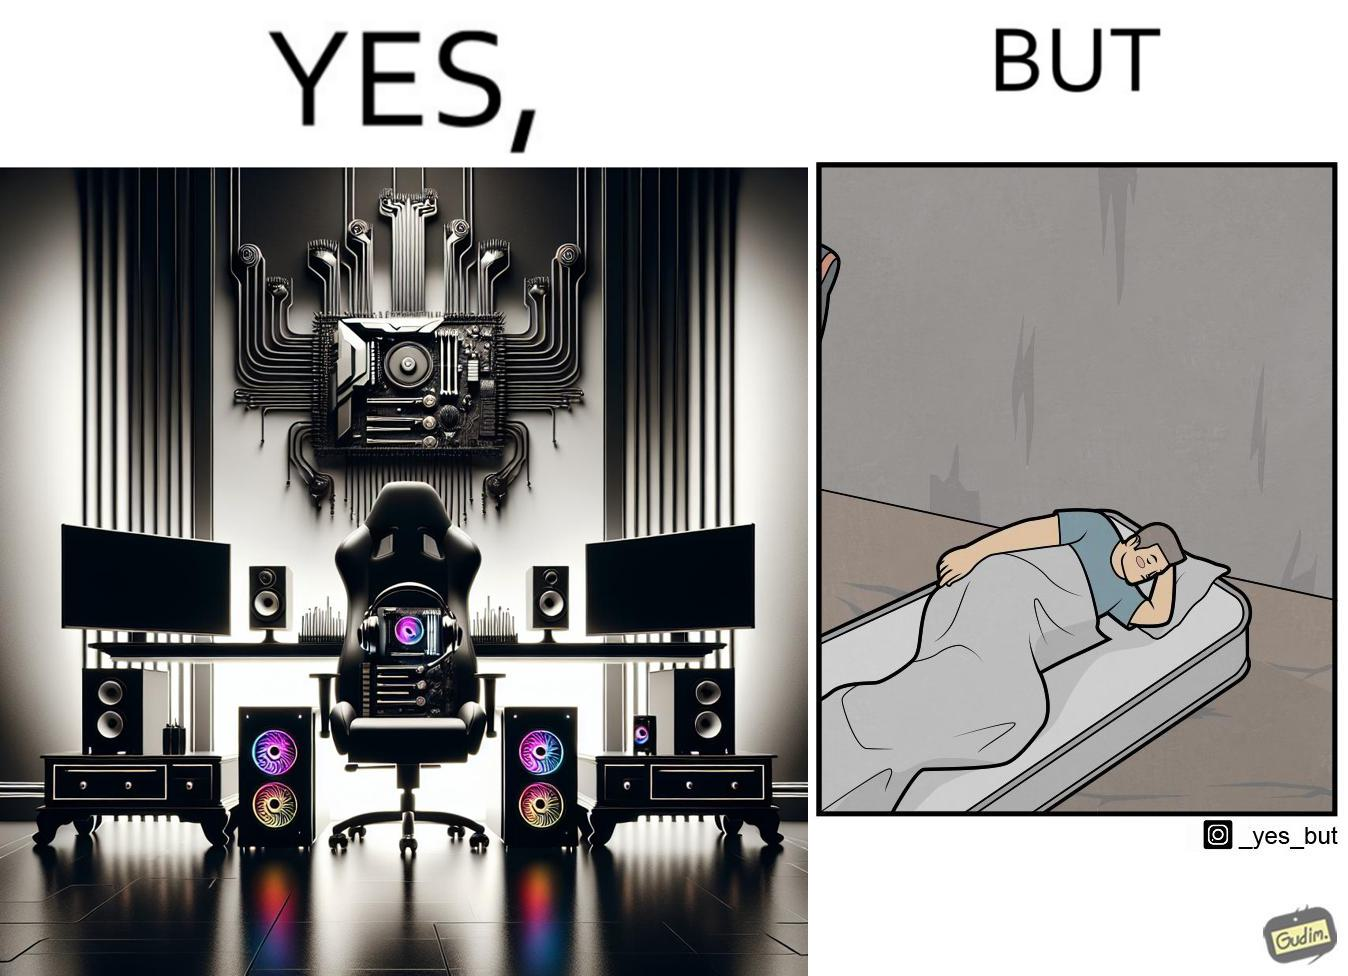Compare the left and right sides of this image. In the left part of the image: The image shows a computer desk with two monitors, two speakers on the side, a headphone hanging off the side of the table, a cpu on the floor with lights glowing on the front of the cpu and a very comfortable looking gaming chair. The whole setup looks high end and expensive. In the right part of the image: The image shows a man sleeping on a mattress on the floor. There does not seem to be a bedsheet on the mattress. 